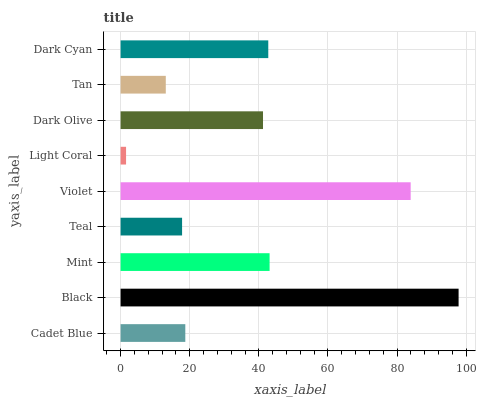Is Light Coral the minimum?
Answer yes or no. Yes. Is Black the maximum?
Answer yes or no. Yes. Is Mint the minimum?
Answer yes or no. No. Is Mint the maximum?
Answer yes or no. No. Is Black greater than Mint?
Answer yes or no. Yes. Is Mint less than Black?
Answer yes or no. Yes. Is Mint greater than Black?
Answer yes or no. No. Is Black less than Mint?
Answer yes or no. No. Is Dark Olive the high median?
Answer yes or no. Yes. Is Dark Olive the low median?
Answer yes or no. Yes. Is Cadet Blue the high median?
Answer yes or no. No. Is Light Coral the low median?
Answer yes or no. No. 